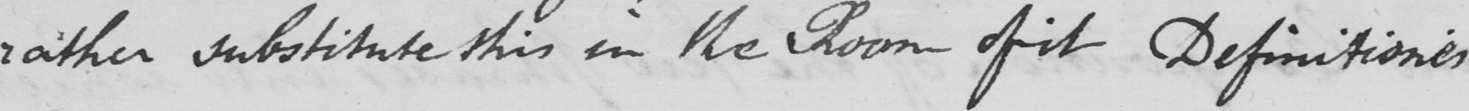Can you tell me what this handwritten text says? rather substitute this in the Room ofit Definitiones 